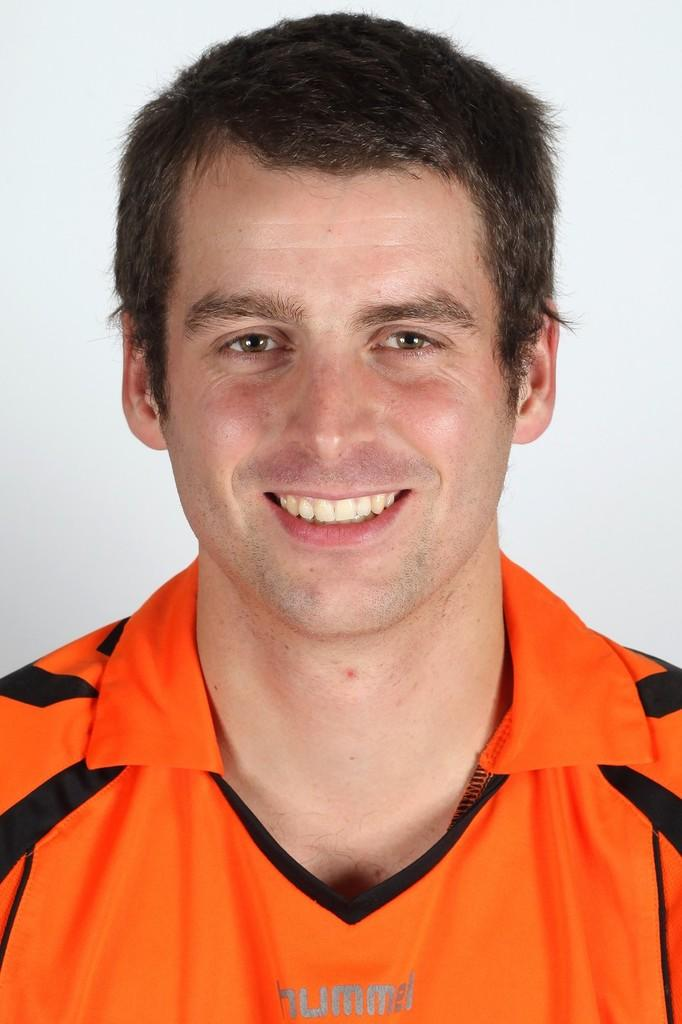Who is present in the image? There is a man in the image. What is the man wearing in the image? The man is wearing an orange T-shirt in the image. What is the color of the background in the image? The background of the image is white. How many eyes does the writer have in the image? There is no writer present in the image, and therefore no eyes can be counted. 